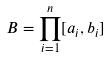<formula> <loc_0><loc_0><loc_500><loc_500>B = \prod _ { i = 1 } ^ { n } [ a _ { i } , b _ { i } ]</formula> 